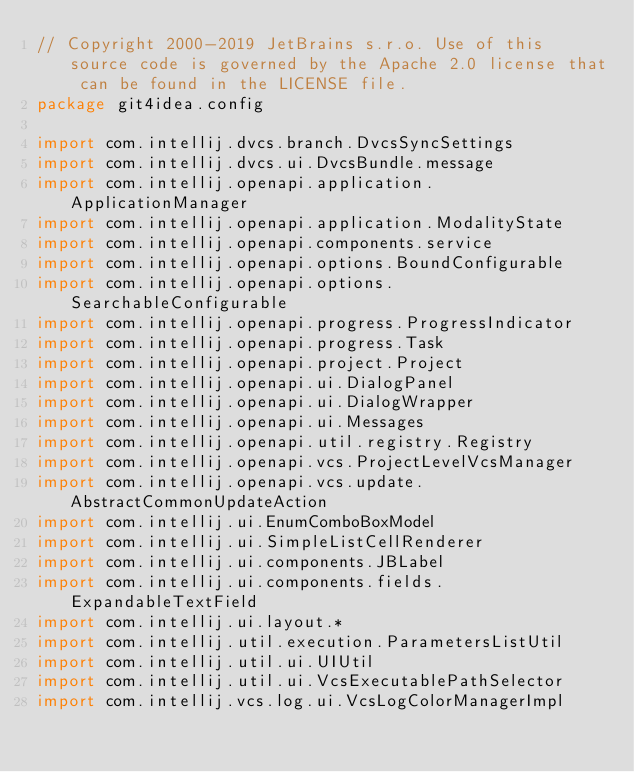Convert code to text. <code><loc_0><loc_0><loc_500><loc_500><_Kotlin_>// Copyright 2000-2019 JetBrains s.r.o. Use of this source code is governed by the Apache 2.0 license that can be found in the LICENSE file.
package git4idea.config

import com.intellij.dvcs.branch.DvcsSyncSettings
import com.intellij.dvcs.ui.DvcsBundle.message
import com.intellij.openapi.application.ApplicationManager
import com.intellij.openapi.application.ModalityState
import com.intellij.openapi.components.service
import com.intellij.openapi.options.BoundConfigurable
import com.intellij.openapi.options.SearchableConfigurable
import com.intellij.openapi.progress.ProgressIndicator
import com.intellij.openapi.progress.Task
import com.intellij.openapi.project.Project
import com.intellij.openapi.ui.DialogPanel
import com.intellij.openapi.ui.DialogWrapper
import com.intellij.openapi.ui.Messages
import com.intellij.openapi.util.registry.Registry
import com.intellij.openapi.vcs.ProjectLevelVcsManager
import com.intellij.openapi.vcs.update.AbstractCommonUpdateAction
import com.intellij.ui.EnumComboBoxModel
import com.intellij.ui.SimpleListCellRenderer
import com.intellij.ui.components.JBLabel
import com.intellij.ui.components.fields.ExpandableTextField
import com.intellij.ui.layout.*
import com.intellij.util.execution.ParametersListUtil
import com.intellij.util.ui.UIUtil
import com.intellij.util.ui.VcsExecutablePathSelector
import com.intellij.vcs.log.ui.VcsLogColorManagerImpl</code> 